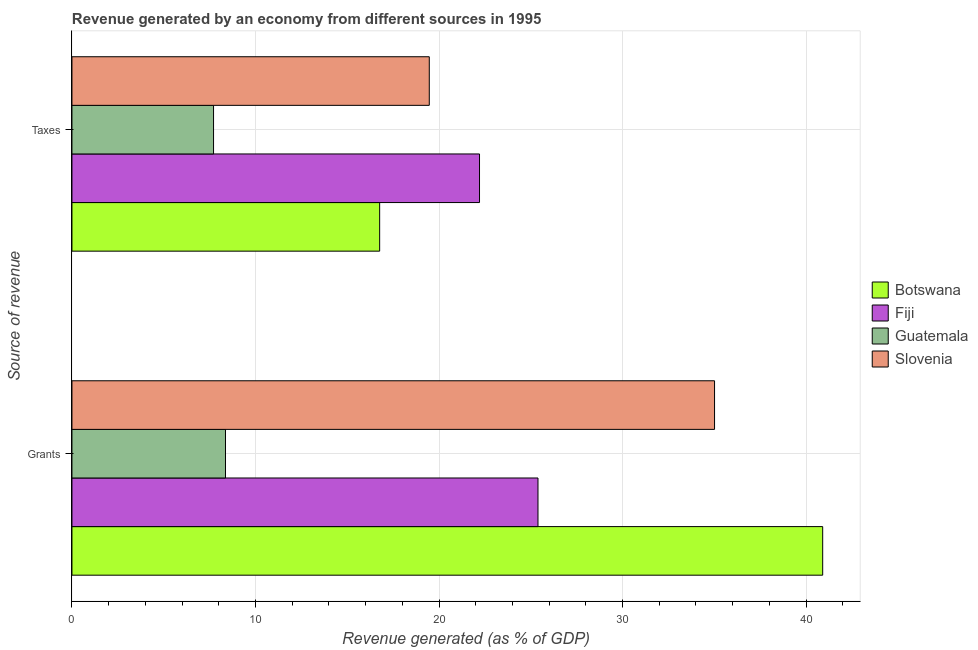How many different coloured bars are there?
Your response must be concise. 4. How many groups of bars are there?
Give a very brief answer. 2. Are the number of bars per tick equal to the number of legend labels?
Provide a short and direct response. Yes. Are the number of bars on each tick of the Y-axis equal?
Offer a terse response. Yes. How many bars are there on the 2nd tick from the top?
Offer a very short reply. 4. How many bars are there on the 2nd tick from the bottom?
Keep it short and to the point. 4. What is the label of the 2nd group of bars from the top?
Make the answer very short. Grants. What is the revenue generated by taxes in Guatemala?
Give a very brief answer. 7.71. Across all countries, what is the maximum revenue generated by grants?
Your answer should be very brief. 40.9. Across all countries, what is the minimum revenue generated by taxes?
Offer a terse response. 7.71. In which country was the revenue generated by grants maximum?
Keep it short and to the point. Botswana. In which country was the revenue generated by taxes minimum?
Give a very brief answer. Guatemala. What is the total revenue generated by grants in the graph?
Offer a very short reply. 109.67. What is the difference between the revenue generated by grants in Botswana and that in Slovenia?
Your answer should be compact. 5.89. What is the difference between the revenue generated by taxes in Guatemala and the revenue generated by grants in Slovenia?
Your answer should be compact. -27.3. What is the average revenue generated by grants per country?
Offer a terse response. 27.42. What is the difference between the revenue generated by grants and revenue generated by taxes in Slovenia?
Offer a terse response. 15.54. What is the ratio of the revenue generated by taxes in Fiji to that in Botswana?
Your answer should be very brief. 1.32. In how many countries, is the revenue generated by taxes greater than the average revenue generated by taxes taken over all countries?
Provide a succinct answer. 3. What does the 3rd bar from the top in Grants represents?
Provide a succinct answer. Fiji. What does the 2nd bar from the bottom in Grants represents?
Provide a short and direct response. Fiji. Are all the bars in the graph horizontal?
Offer a terse response. Yes. How many countries are there in the graph?
Provide a succinct answer. 4. Are the values on the major ticks of X-axis written in scientific E-notation?
Offer a very short reply. No. Does the graph contain any zero values?
Offer a terse response. No. Where does the legend appear in the graph?
Make the answer very short. Center right. How many legend labels are there?
Your answer should be very brief. 4. What is the title of the graph?
Keep it short and to the point. Revenue generated by an economy from different sources in 1995. What is the label or title of the X-axis?
Make the answer very short. Revenue generated (as % of GDP). What is the label or title of the Y-axis?
Ensure brevity in your answer.  Source of revenue. What is the Revenue generated (as % of GDP) of Botswana in Grants?
Your answer should be very brief. 40.9. What is the Revenue generated (as % of GDP) in Fiji in Grants?
Your answer should be compact. 25.39. What is the Revenue generated (as % of GDP) in Guatemala in Grants?
Make the answer very short. 8.37. What is the Revenue generated (as % of GDP) in Slovenia in Grants?
Provide a short and direct response. 35.01. What is the Revenue generated (as % of GDP) in Botswana in Taxes?
Your answer should be very brief. 16.77. What is the Revenue generated (as % of GDP) of Fiji in Taxes?
Provide a succinct answer. 22.21. What is the Revenue generated (as % of GDP) of Guatemala in Taxes?
Provide a succinct answer. 7.71. What is the Revenue generated (as % of GDP) of Slovenia in Taxes?
Ensure brevity in your answer.  19.47. Across all Source of revenue, what is the maximum Revenue generated (as % of GDP) of Botswana?
Your response must be concise. 40.9. Across all Source of revenue, what is the maximum Revenue generated (as % of GDP) in Fiji?
Ensure brevity in your answer.  25.39. Across all Source of revenue, what is the maximum Revenue generated (as % of GDP) in Guatemala?
Keep it short and to the point. 8.37. Across all Source of revenue, what is the maximum Revenue generated (as % of GDP) of Slovenia?
Provide a short and direct response. 35.01. Across all Source of revenue, what is the minimum Revenue generated (as % of GDP) in Botswana?
Give a very brief answer. 16.77. Across all Source of revenue, what is the minimum Revenue generated (as % of GDP) of Fiji?
Your answer should be very brief. 22.21. Across all Source of revenue, what is the minimum Revenue generated (as % of GDP) of Guatemala?
Provide a short and direct response. 7.71. Across all Source of revenue, what is the minimum Revenue generated (as % of GDP) of Slovenia?
Offer a terse response. 19.47. What is the total Revenue generated (as % of GDP) in Botswana in the graph?
Your answer should be very brief. 57.67. What is the total Revenue generated (as % of GDP) in Fiji in the graph?
Ensure brevity in your answer.  47.6. What is the total Revenue generated (as % of GDP) in Guatemala in the graph?
Ensure brevity in your answer.  16.08. What is the total Revenue generated (as % of GDP) of Slovenia in the graph?
Your response must be concise. 54.48. What is the difference between the Revenue generated (as % of GDP) of Botswana in Grants and that in Taxes?
Your answer should be compact. 24.14. What is the difference between the Revenue generated (as % of GDP) in Fiji in Grants and that in Taxes?
Offer a terse response. 3.19. What is the difference between the Revenue generated (as % of GDP) in Guatemala in Grants and that in Taxes?
Offer a terse response. 0.65. What is the difference between the Revenue generated (as % of GDP) of Slovenia in Grants and that in Taxes?
Your response must be concise. 15.54. What is the difference between the Revenue generated (as % of GDP) in Botswana in Grants and the Revenue generated (as % of GDP) in Fiji in Taxes?
Provide a short and direct response. 18.7. What is the difference between the Revenue generated (as % of GDP) of Botswana in Grants and the Revenue generated (as % of GDP) of Guatemala in Taxes?
Provide a short and direct response. 33.19. What is the difference between the Revenue generated (as % of GDP) of Botswana in Grants and the Revenue generated (as % of GDP) of Slovenia in Taxes?
Provide a succinct answer. 21.44. What is the difference between the Revenue generated (as % of GDP) in Fiji in Grants and the Revenue generated (as % of GDP) in Guatemala in Taxes?
Your answer should be compact. 17.68. What is the difference between the Revenue generated (as % of GDP) of Fiji in Grants and the Revenue generated (as % of GDP) of Slovenia in Taxes?
Keep it short and to the point. 5.92. What is the difference between the Revenue generated (as % of GDP) in Guatemala in Grants and the Revenue generated (as % of GDP) in Slovenia in Taxes?
Offer a terse response. -11.1. What is the average Revenue generated (as % of GDP) in Botswana per Source of revenue?
Provide a short and direct response. 28.84. What is the average Revenue generated (as % of GDP) in Fiji per Source of revenue?
Your response must be concise. 23.8. What is the average Revenue generated (as % of GDP) of Guatemala per Source of revenue?
Offer a very short reply. 8.04. What is the average Revenue generated (as % of GDP) of Slovenia per Source of revenue?
Provide a succinct answer. 27.24. What is the difference between the Revenue generated (as % of GDP) in Botswana and Revenue generated (as % of GDP) in Fiji in Grants?
Offer a terse response. 15.51. What is the difference between the Revenue generated (as % of GDP) of Botswana and Revenue generated (as % of GDP) of Guatemala in Grants?
Offer a terse response. 32.54. What is the difference between the Revenue generated (as % of GDP) of Botswana and Revenue generated (as % of GDP) of Slovenia in Grants?
Give a very brief answer. 5.89. What is the difference between the Revenue generated (as % of GDP) of Fiji and Revenue generated (as % of GDP) of Guatemala in Grants?
Provide a short and direct response. 17.03. What is the difference between the Revenue generated (as % of GDP) of Fiji and Revenue generated (as % of GDP) of Slovenia in Grants?
Make the answer very short. -9.62. What is the difference between the Revenue generated (as % of GDP) in Guatemala and Revenue generated (as % of GDP) in Slovenia in Grants?
Your answer should be compact. -26.65. What is the difference between the Revenue generated (as % of GDP) of Botswana and Revenue generated (as % of GDP) of Fiji in Taxes?
Ensure brevity in your answer.  -5.44. What is the difference between the Revenue generated (as % of GDP) of Botswana and Revenue generated (as % of GDP) of Guatemala in Taxes?
Ensure brevity in your answer.  9.05. What is the difference between the Revenue generated (as % of GDP) in Botswana and Revenue generated (as % of GDP) in Slovenia in Taxes?
Your response must be concise. -2.7. What is the difference between the Revenue generated (as % of GDP) in Fiji and Revenue generated (as % of GDP) in Guatemala in Taxes?
Offer a very short reply. 14.49. What is the difference between the Revenue generated (as % of GDP) in Fiji and Revenue generated (as % of GDP) in Slovenia in Taxes?
Your answer should be compact. 2.74. What is the difference between the Revenue generated (as % of GDP) of Guatemala and Revenue generated (as % of GDP) of Slovenia in Taxes?
Provide a succinct answer. -11.75. What is the ratio of the Revenue generated (as % of GDP) in Botswana in Grants to that in Taxes?
Your answer should be compact. 2.44. What is the ratio of the Revenue generated (as % of GDP) of Fiji in Grants to that in Taxes?
Provide a short and direct response. 1.14. What is the ratio of the Revenue generated (as % of GDP) of Guatemala in Grants to that in Taxes?
Provide a short and direct response. 1.08. What is the ratio of the Revenue generated (as % of GDP) of Slovenia in Grants to that in Taxes?
Offer a very short reply. 1.8. What is the difference between the highest and the second highest Revenue generated (as % of GDP) of Botswana?
Offer a very short reply. 24.14. What is the difference between the highest and the second highest Revenue generated (as % of GDP) of Fiji?
Your answer should be compact. 3.19. What is the difference between the highest and the second highest Revenue generated (as % of GDP) in Guatemala?
Offer a very short reply. 0.65. What is the difference between the highest and the second highest Revenue generated (as % of GDP) in Slovenia?
Your response must be concise. 15.54. What is the difference between the highest and the lowest Revenue generated (as % of GDP) of Botswana?
Ensure brevity in your answer.  24.14. What is the difference between the highest and the lowest Revenue generated (as % of GDP) in Fiji?
Make the answer very short. 3.19. What is the difference between the highest and the lowest Revenue generated (as % of GDP) of Guatemala?
Give a very brief answer. 0.65. What is the difference between the highest and the lowest Revenue generated (as % of GDP) of Slovenia?
Provide a succinct answer. 15.54. 